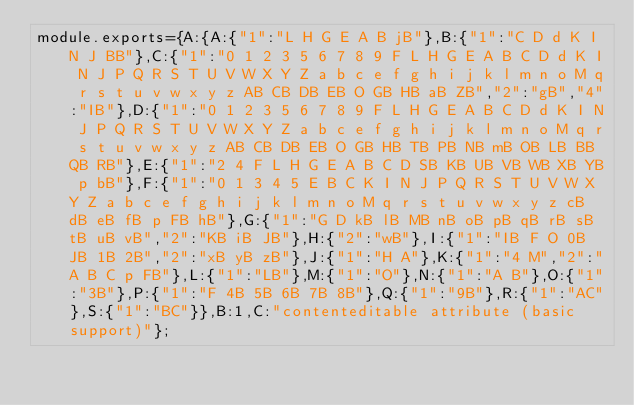Convert code to text. <code><loc_0><loc_0><loc_500><loc_500><_JavaScript_>module.exports={A:{A:{"1":"L H G E A B jB"},B:{"1":"C D d K I N J BB"},C:{"1":"0 1 2 3 5 6 7 8 9 F L H G E A B C D d K I N J P Q R S T U V W X Y Z a b c e f g h i j k l m n o M q r s t u v w x y z AB CB DB EB O GB HB aB ZB","2":"gB","4":"IB"},D:{"1":"0 1 2 3 5 6 7 8 9 F L H G E A B C D d K I N J P Q R S T U V W X Y Z a b c e f g h i j k l m n o M q r s t u v w x y z AB CB DB EB O GB HB TB PB NB mB OB LB BB QB RB"},E:{"1":"2 4 F L H G E A B C D SB KB UB VB WB XB YB p bB"},F:{"1":"0 1 3 4 5 E B C K I N J P Q R S T U V W X Y Z a b c e f g h i j k l m n o M q r s t u v w x y z cB dB eB fB p FB hB"},G:{"1":"G D kB lB MB nB oB pB qB rB sB tB uB vB","2":"KB iB JB"},H:{"2":"wB"},I:{"1":"IB F O 0B JB 1B 2B","2":"xB yB zB"},J:{"1":"H A"},K:{"1":"4 M","2":"A B C p FB"},L:{"1":"LB"},M:{"1":"O"},N:{"1":"A B"},O:{"1":"3B"},P:{"1":"F 4B 5B 6B 7B 8B"},Q:{"1":"9B"},R:{"1":"AC"},S:{"1":"BC"}},B:1,C:"contenteditable attribute (basic support)"};
</code> 